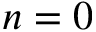<formula> <loc_0><loc_0><loc_500><loc_500>n = 0</formula> 